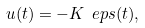Convert formula to latex. <formula><loc_0><loc_0><loc_500><loc_500>u ( t ) = - K \ e p s ( t ) ,</formula> 